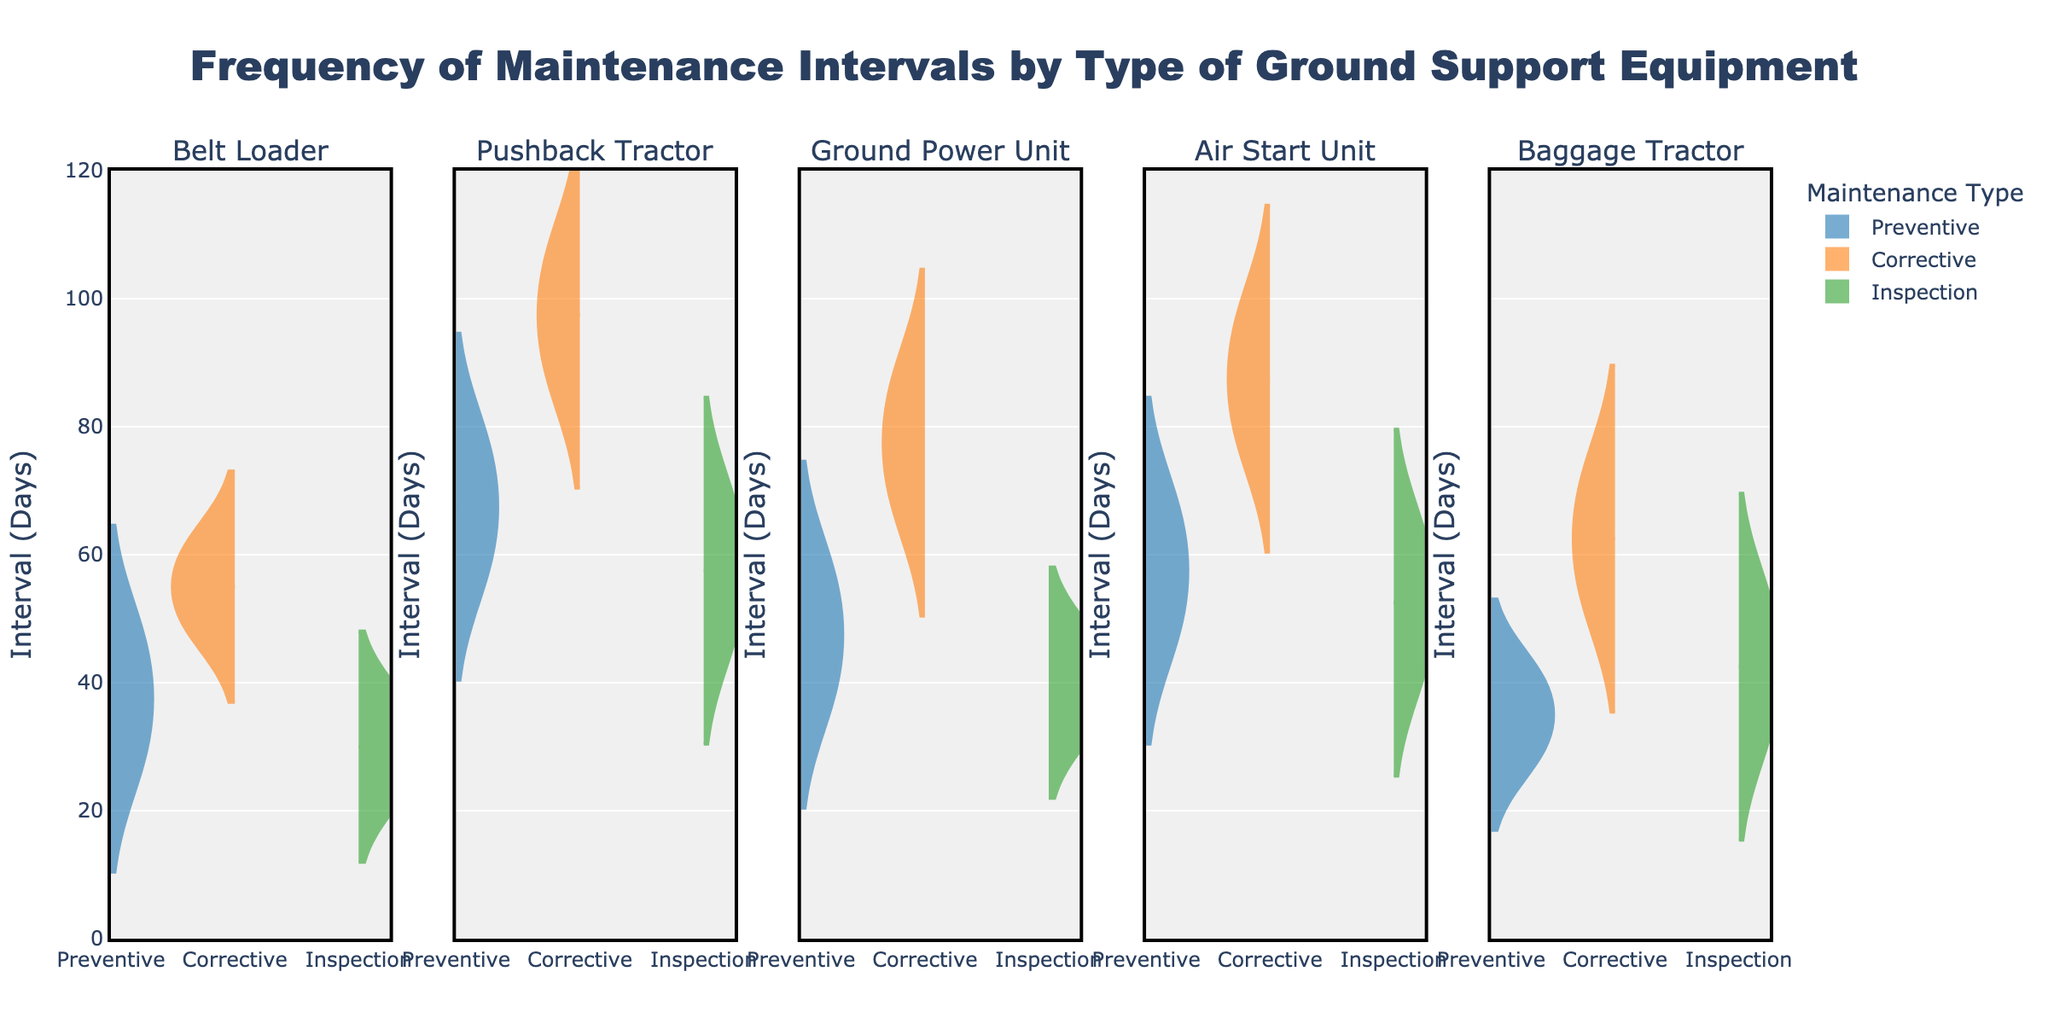What is the title of the figure? The title is usually located at the top of the figure. In this case, it's "Frequency of Maintenance Intervals by Type of Ground Support Equipment."
Answer: Frequency of Maintenance Intervals by Type of Ground Support Equipment What are the different types of ground support equipment shown in the figure? The subplots are labeled with the names of the different equipment types. They are "Belt Loader," "Pushback Tractor," "Ground Power Unit," "Air Start Unit," and "Baggage Tractor."
Answer: Belt Loader, Pushback Tractor, Ground Power Unit, Air Start Unit, Baggage Tractor How many maintenance types are represented in each subplot? Each subplot contains three different colors representing different maintenance types. By referring to the legend, the maintenance types are "Preventive," "Corrective," and "Inspection."
Answer: 3 Which maintenance type has the highest interval days for "Pushback Tractor"? The violin plot for "Pushback Tractor" shows the highest range for "Corrective" maintenance. The maximum interval days can be seen from the peak of the "Corrective" violin plot.
Answer: Corrective What is the average interval day for "Preventive" maintenance of "Air Start Unit"? The meanline (indicated by a horizontal line in the violin plot) represents the average interval days. For "Preventive" maintenance of "Air Start Unit," this can be visually examined from the plot.
Answer: ~57.5 How do the interval days for "Corrective" maintenance of "Ground Power Unit" compare with "Inspection" maintenance for the same equipment type? Comparing the positions of the violin plots for "Corrective" and "Inspection", the "Corrective" maintenance for "Ground Power Unit" shows larger average interval days compared to "Inspection."
Answer: Corrective is higher Which equipment type has the narrowest range of interval days for "Inspection" maintenance? To find this, observe the width and spread of the "Inspection" violin plots across all subplots. "Ground Power Unit" shows the narrowest range for "Inspection" maintenance.
Answer: Ground Power Unit What can you infer about the frequency of "Preventive" maintenance compared to "Corrective" maintenance across equipment types? Analyzing the violin plots for each equipment type, "Preventive" maintenance generally has lower interval days compared to "Corrective," indicating more frequent preventive maintenance activities.
Answer: Preventive is more frequent Which maintenance type shows the least variability for "Baggage Tractor"? The narrowness or spread of the violin plot indicates variability. For "Baggage Tractor," the "Preventive" maintenance type shows the least variability.
Answer: Preventive 